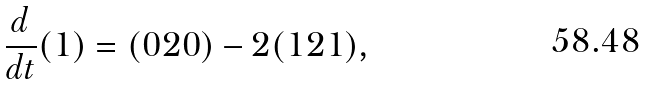Convert formula to latex. <formula><loc_0><loc_0><loc_500><loc_500>\frac { d } { d t } ( 1 ) = ( 0 2 0 ) - 2 ( 1 2 1 ) ,</formula> 